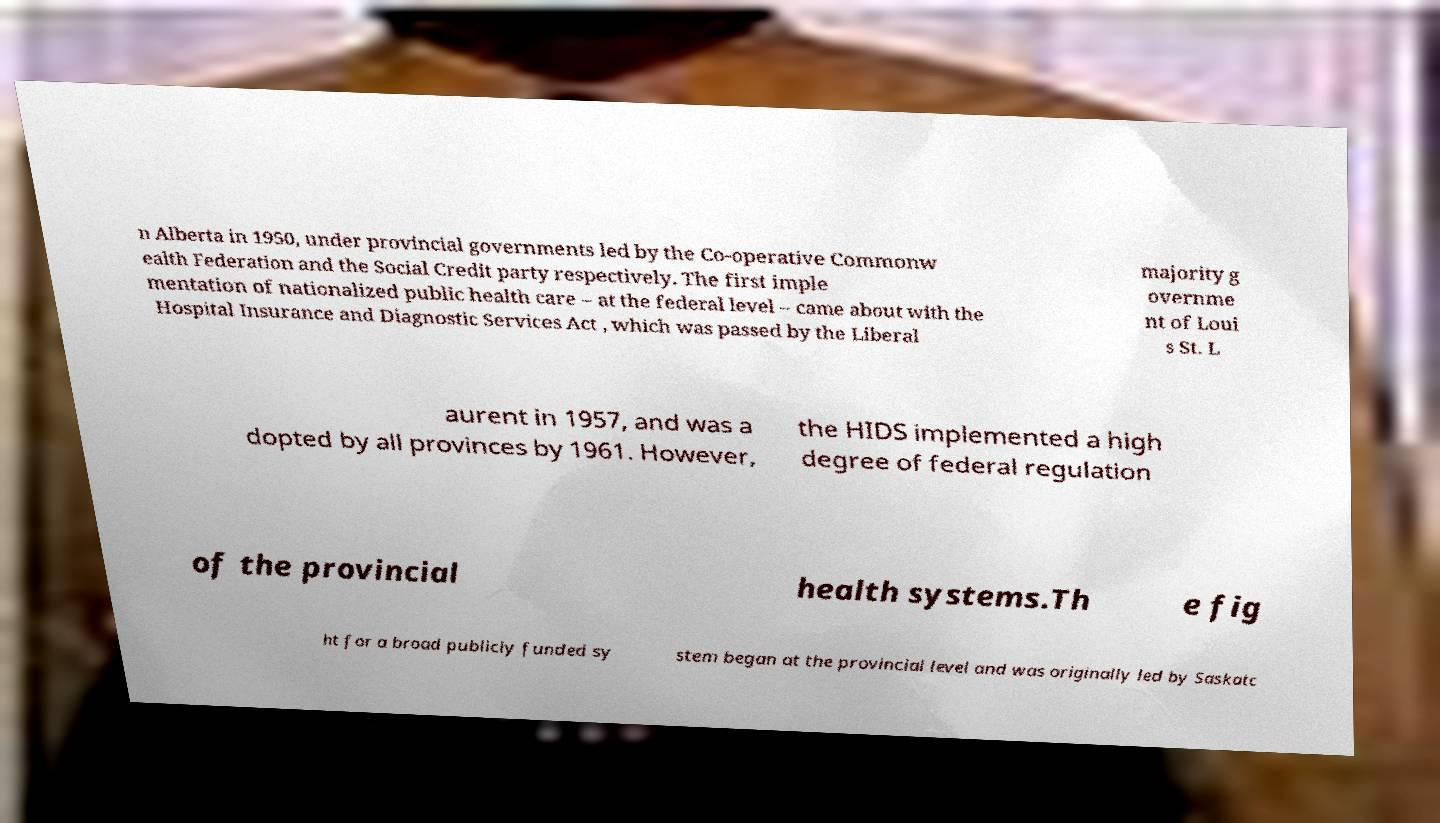There's text embedded in this image that I need extracted. Can you transcribe it verbatim? n Alberta in 1950, under provincial governments led by the Co-operative Commonw ealth Federation and the Social Credit party respectively. The first imple mentation of nationalized public health care – at the federal level – came about with the Hospital Insurance and Diagnostic Services Act , which was passed by the Liberal majority g overnme nt of Loui s St. L aurent in 1957, and was a dopted by all provinces by 1961. However, the HIDS implemented a high degree of federal regulation of the provincial health systems.Th e fig ht for a broad publicly funded sy stem began at the provincial level and was originally led by Saskatc 